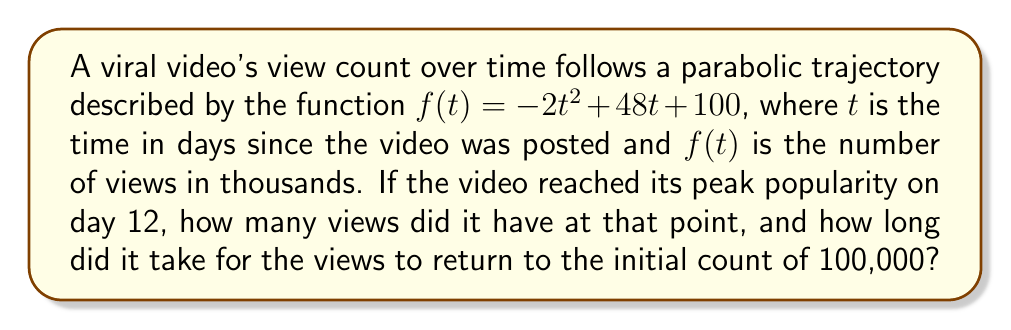Could you help me with this problem? 1. The parabola's vertex represents the peak popularity. To find the t-coordinate of the vertex, use the formula $t = -\frac{b}{2a}$:

   $t = -\frac{48}{2(-2)} = 12$ days

2. To find the number of views at peak popularity, substitute $t=12$ into the function:

   $f(12) = -2(12)^2 + 48(12) + 100$
   $= -2(144) + 576 + 100$
   $= -288 + 576 + 100$
   $= 388$ thousand views

3. To find when the views return to 100,000, set $f(t) = 100$ and solve:

   $-2t^2 + 48t + 100 = 100$
   $-2t^2 + 48t = 0$
   $-2t(t - 24) = 0$

   Solving this equation gives $t = 0$ or $t = 24$

4. Since we're looking for the time after the peak, the solution is $t = 24$ days.

[asy]
import graph;
size(200,200);
real f(real x) {return -2x^2+48x+100;}
xaxis("t (days)",arrow=Arrow);
yaxis("Views (thousands)",arrow=Arrow);
draw(graph(f,0,24));
dot((12,388),red);
dot((0,100),blue);
dot((24,100),blue);
label("Peak",(12,388),NE);
label("Start",(0,100),SW);
label("End",(24,100),SE);
[/asy]
Answer: 388,000 views at peak; 24 days to return to initial count 